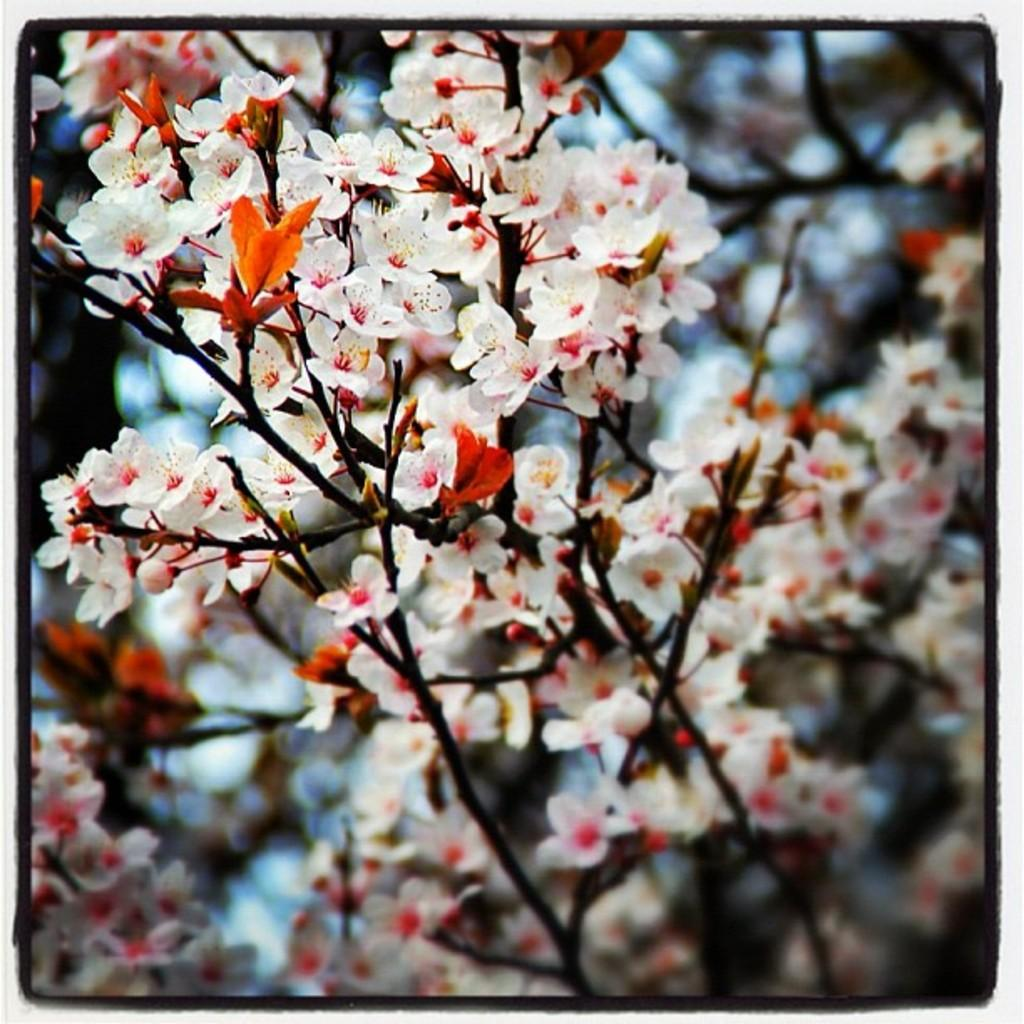What color are the flowers in the image? The flowers in the image are white. What type of plant do the flowers belong to? The flowers belong to a plant. Can you describe the appearance of the image? The corners of the image are blurred. How many wings does the flower have in the image? Flowers do not have wings; they have petals. The flower in the image has multiple petals, but no wings. 